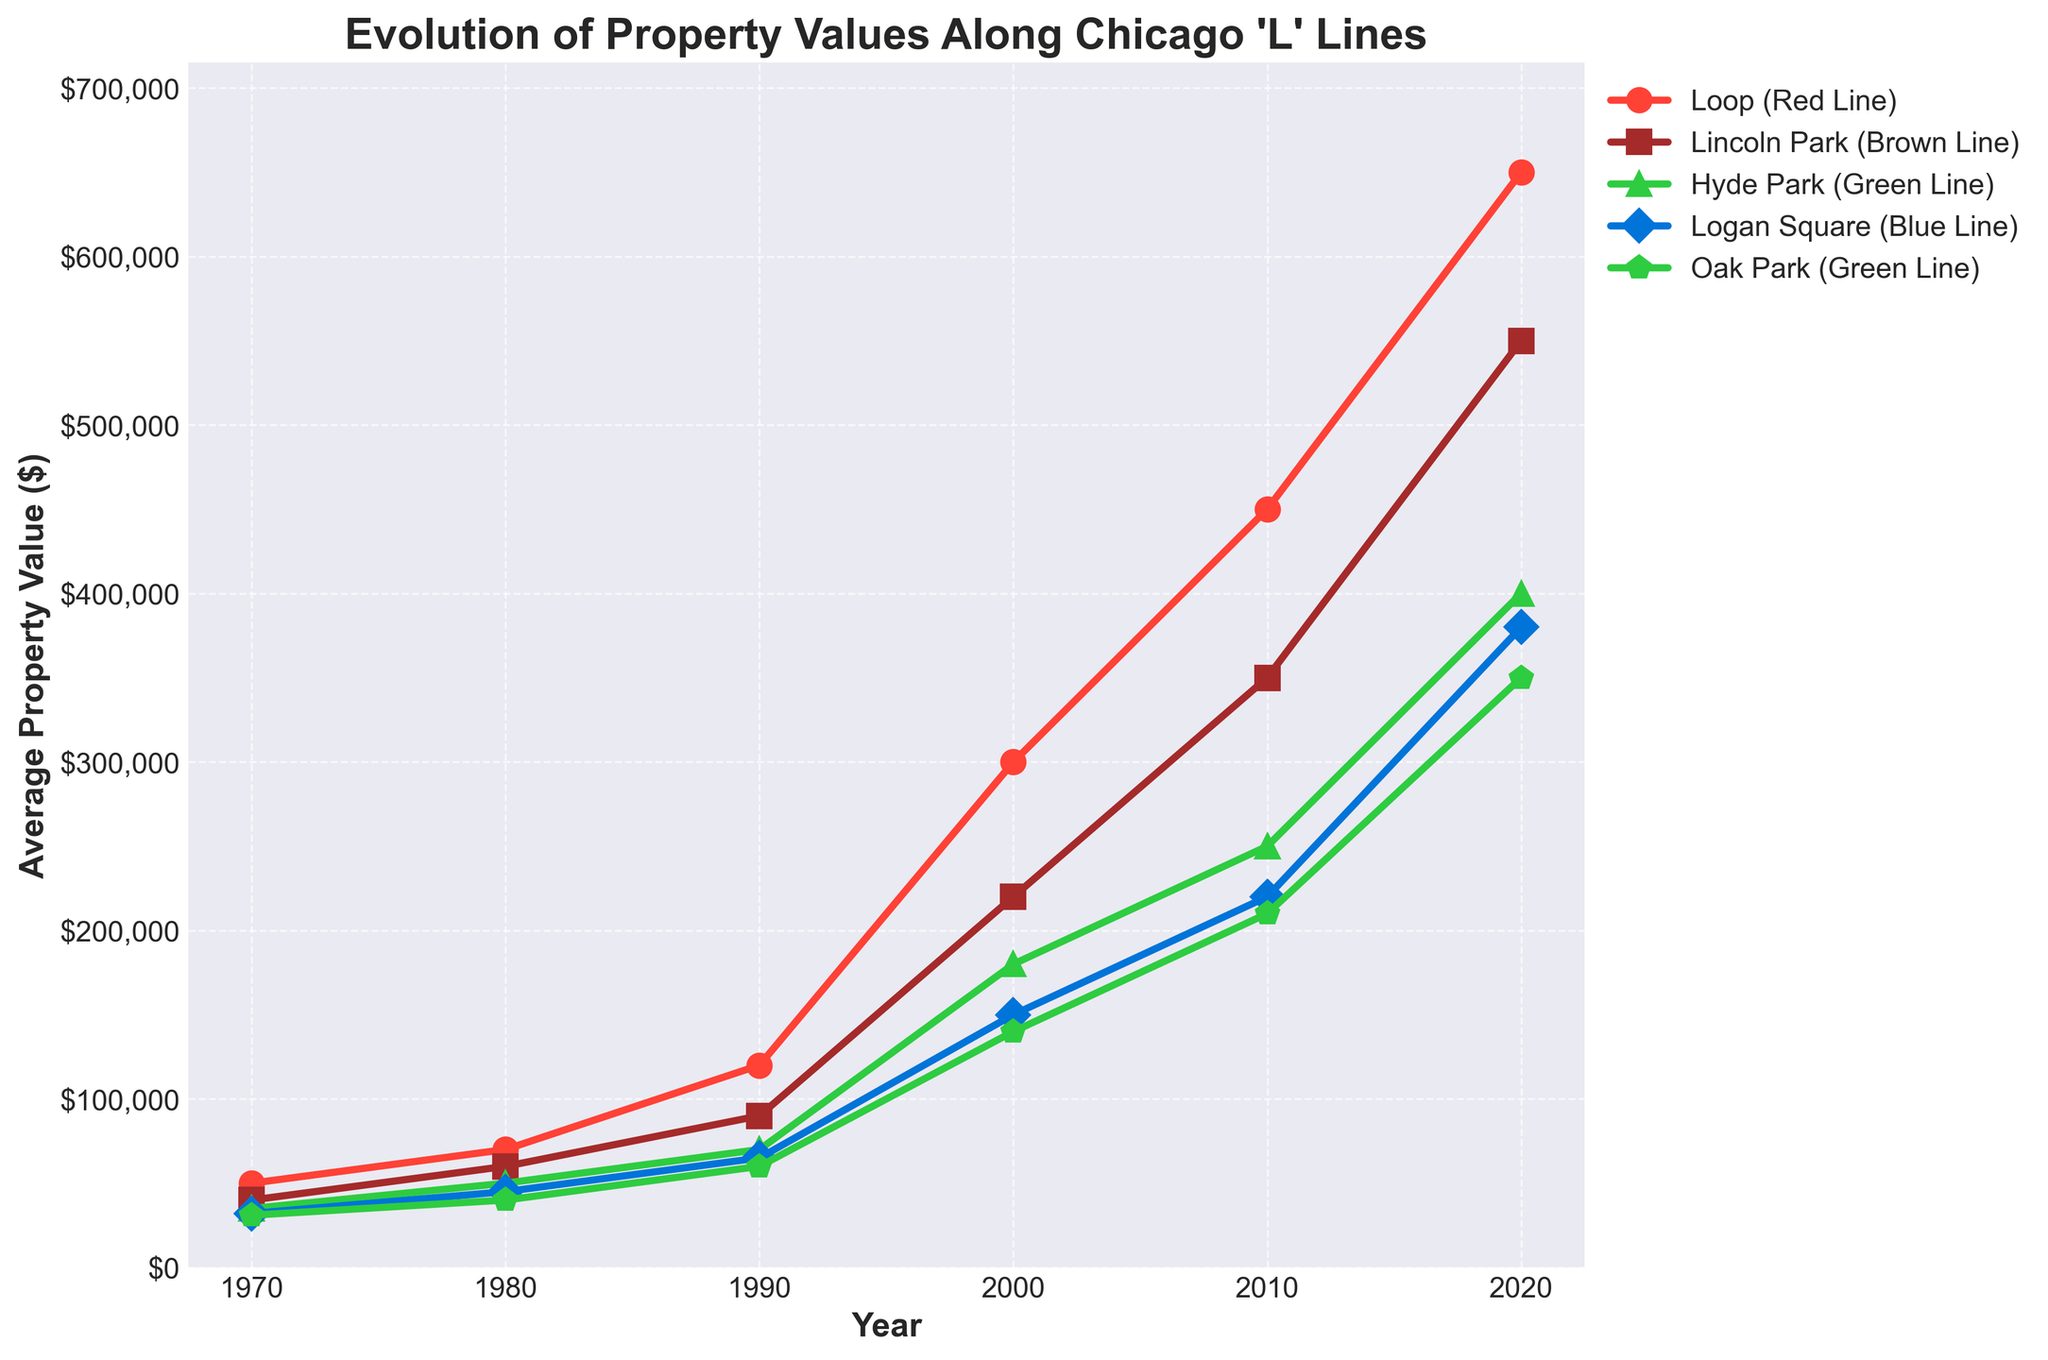What's the title of the plot? The title of the plot is displayed at the top center and describes the overall content of the figure.
Answer: Evolution of Property Values Along Chicago 'L' Lines Which neighborhood had the highest average property value in 2020? Look at the data points for the year 2020 and identify the highest value. The Loop, marked with a circle and red color, has the highest average property value.
Answer: Loop How did the average property value in Lincoln Park change from 1970 to 2020? Observe the data points for Lincoln Park, marked with a square and brown color, and note the values in 1970 and 2020. In 1970, the value was $40,000, and in 2020, it was $550,000. Subtract the 1970 value from the 2020 value to find the change.
Answer: $510,000 increase Which neighborhood experienced the largest increase in property values between any two decades? Compare the differences in property values for each neighborhood between each decade. The Loop saw a significant increase from 1990 ($120,000) to 2000 ($300,000), which is $180,000, the largest among all neighborhoods and decades.
Answer: The Loop Compare the property values of Hyde Park in 1970 and 2000. What is the percentage increase? Note the values for Hyde Park in 1970 ($35,000) and 2000 ($180,000). Compute the percentage increase using the formula ((2000 value - 1970 value) / 1970 value) * 100.
Answer: 414.29% How much did the average property value in Logan Square increase from 1980 to 2010? Note the values for Logan Square in 1980 ($45,000) and 2010 ($220,000). Subtract the 1980 value from the 2010 value to find the increase.
Answer: $175,000 Were property values generally higher in neighborhoods on the Green Line or the Red Line in 2020? Compare the average property values of the neighborhoods on the Green Line (Hyde Park and Oak Park) with those on the Red Line (Loop) in 2020. Hyde Park and Oak Park are $400,000 and $350,000 respectively, whereas the Loop is $650,000, so the Red Line has higher values.
Answer: Red Line How did property values change in Hyde Park over the entire period from 1970 to 2020? Examine the plot points for Hyde Park over the years, tracking the values from 1970 ($35,000) to 2020 ($400,000). There is a steady increase over this period.
Answer: Steady increase Which neighborhood had the smallest increase in property values from 2000 to 2010? Compare the values for all neighborhoods across the 2000 to 2010 period. Logan Square's increase from $150,000 to $220,000, a $70,000 increase, is the smallest.
Answer: Logan Square 